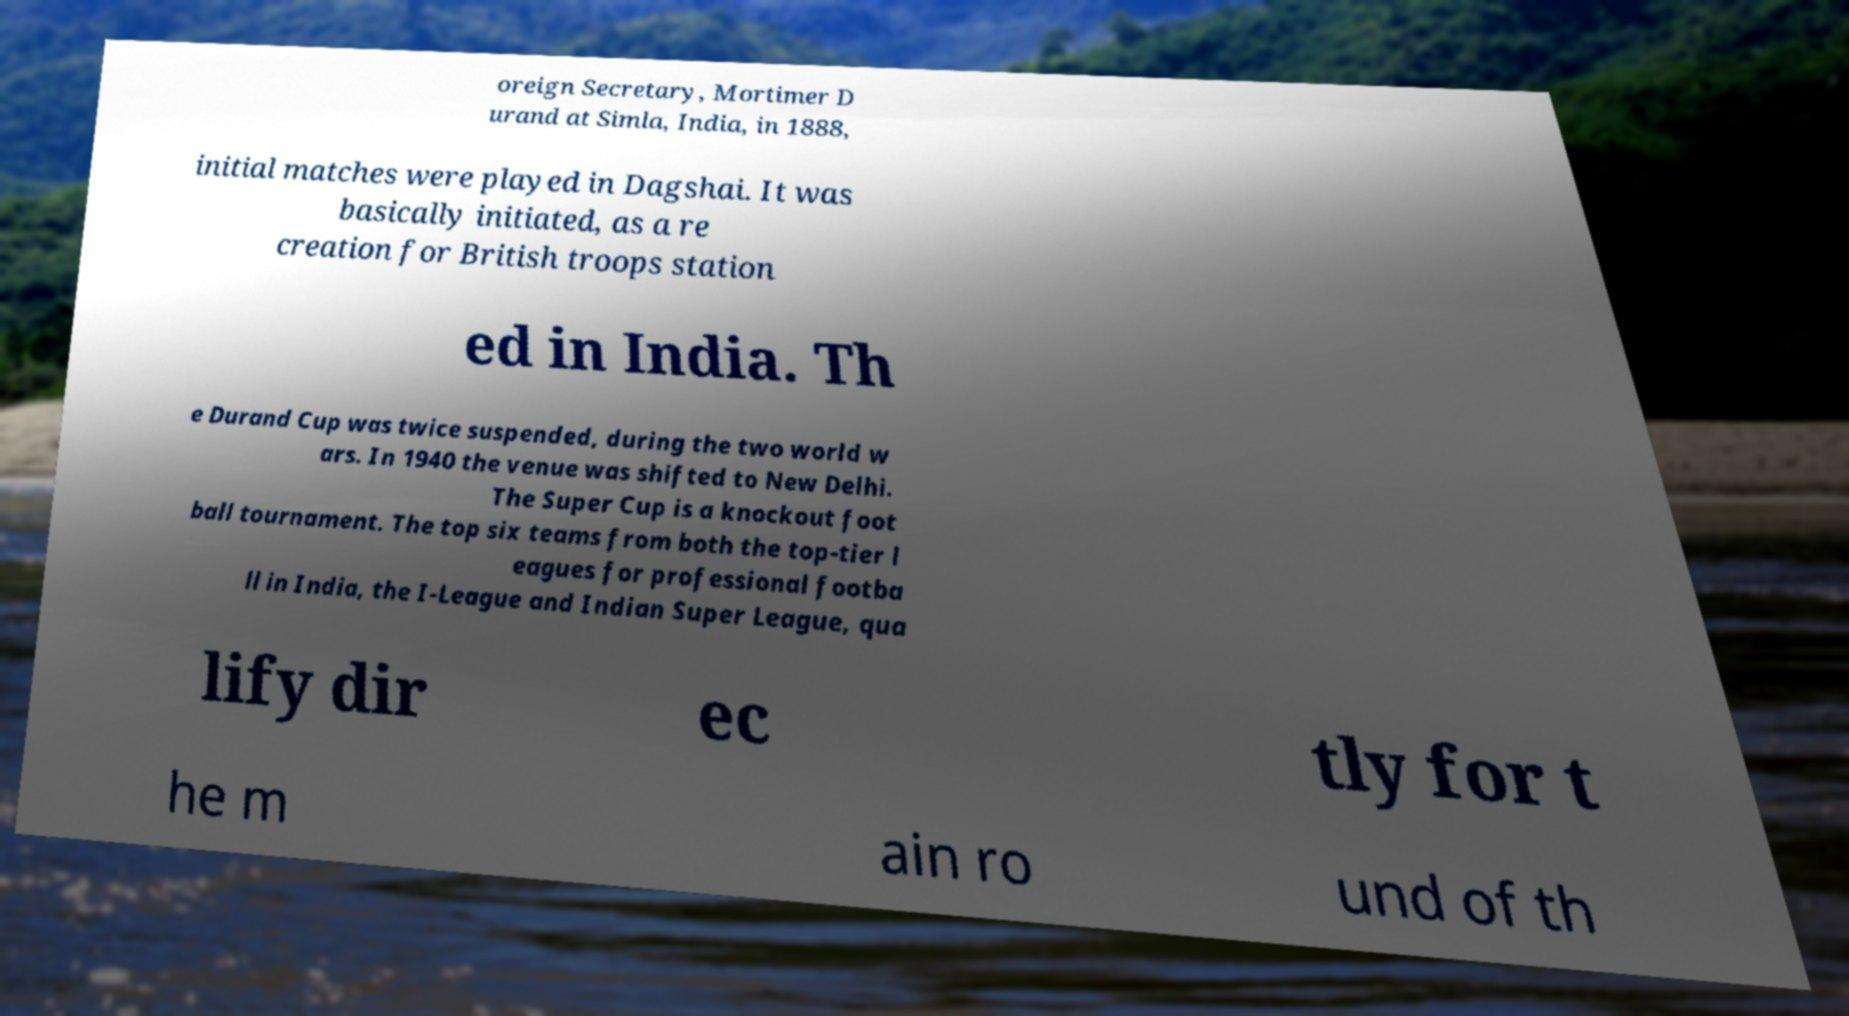Please identify and transcribe the text found in this image. oreign Secretary, Mortimer D urand at Simla, India, in 1888, initial matches were played in Dagshai. It was basically initiated, as a re creation for British troops station ed in India. Th e Durand Cup was twice suspended, during the two world w ars. In 1940 the venue was shifted to New Delhi. The Super Cup is a knockout foot ball tournament. The top six teams from both the top-tier l eagues for professional footba ll in India, the I-League and Indian Super League, qua lify dir ec tly for t he m ain ro und of th 